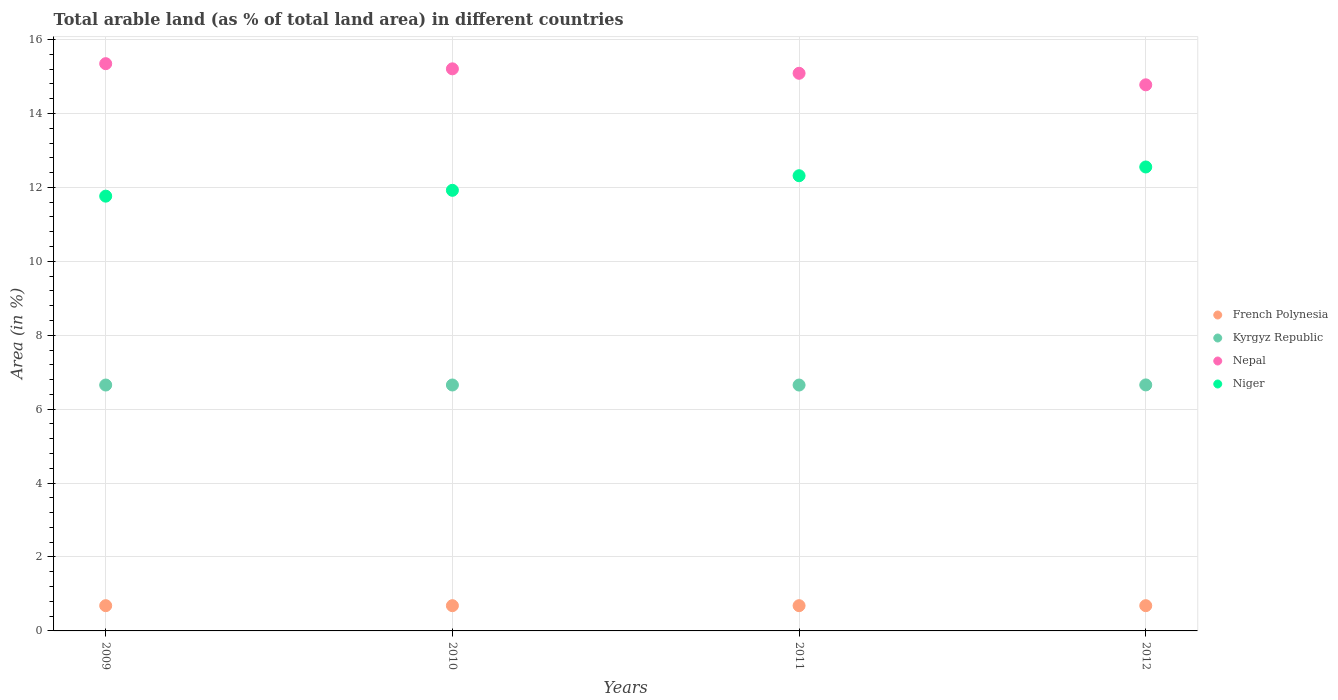Is the number of dotlines equal to the number of legend labels?
Your answer should be very brief. Yes. What is the percentage of arable land in French Polynesia in 2012?
Your answer should be compact. 0.68. Across all years, what is the maximum percentage of arable land in Nepal?
Ensure brevity in your answer.  15.35. Across all years, what is the minimum percentage of arable land in Kyrgyz Republic?
Make the answer very short. 6.65. In which year was the percentage of arable land in Niger maximum?
Give a very brief answer. 2012. In which year was the percentage of arable land in Nepal minimum?
Make the answer very short. 2012. What is the total percentage of arable land in Niger in the graph?
Ensure brevity in your answer.  48.55. What is the difference between the percentage of arable land in Kyrgyz Republic in 2009 and that in 2010?
Your response must be concise. -0. What is the difference between the percentage of arable land in Nepal in 2011 and the percentage of arable land in Niger in 2012?
Ensure brevity in your answer.  2.53. What is the average percentage of arable land in Nepal per year?
Your response must be concise. 15.1. In the year 2011, what is the difference between the percentage of arable land in Nepal and percentage of arable land in Niger?
Your answer should be very brief. 2.77. In how many years, is the percentage of arable land in Nepal greater than 4 %?
Provide a succinct answer. 4. What is the ratio of the percentage of arable land in Kyrgyz Republic in 2009 to that in 2012?
Provide a short and direct response. 1. Is the difference between the percentage of arable land in Nepal in 2009 and 2011 greater than the difference between the percentage of arable land in Niger in 2009 and 2011?
Your answer should be very brief. Yes. What is the difference between the highest and the second highest percentage of arable land in Niger?
Offer a terse response. 0.24. What is the difference between the highest and the lowest percentage of arable land in French Polynesia?
Keep it short and to the point. 0. In how many years, is the percentage of arable land in Nepal greater than the average percentage of arable land in Nepal taken over all years?
Your response must be concise. 2. Is it the case that in every year, the sum of the percentage of arable land in Nepal and percentage of arable land in French Polynesia  is greater than the sum of percentage of arable land in Niger and percentage of arable land in Kyrgyz Republic?
Provide a succinct answer. No. Is it the case that in every year, the sum of the percentage of arable land in French Polynesia and percentage of arable land in Nepal  is greater than the percentage of arable land in Kyrgyz Republic?
Provide a succinct answer. Yes. Is the percentage of arable land in French Polynesia strictly less than the percentage of arable land in Kyrgyz Republic over the years?
Your answer should be very brief. Yes. How many dotlines are there?
Provide a short and direct response. 4. How many years are there in the graph?
Provide a short and direct response. 4. What is the difference between two consecutive major ticks on the Y-axis?
Your answer should be very brief. 2. Does the graph contain grids?
Give a very brief answer. Yes. How many legend labels are there?
Ensure brevity in your answer.  4. What is the title of the graph?
Keep it short and to the point. Total arable land (as % of total land area) in different countries. What is the label or title of the X-axis?
Your answer should be very brief. Years. What is the label or title of the Y-axis?
Make the answer very short. Area (in %). What is the Area (in %) in French Polynesia in 2009?
Your answer should be very brief. 0.68. What is the Area (in %) in Kyrgyz Republic in 2009?
Your answer should be compact. 6.65. What is the Area (in %) of Nepal in 2009?
Provide a succinct answer. 15.35. What is the Area (in %) in Niger in 2009?
Your answer should be compact. 11.76. What is the Area (in %) of French Polynesia in 2010?
Your response must be concise. 0.68. What is the Area (in %) in Kyrgyz Republic in 2010?
Ensure brevity in your answer.  6.65. What is the Area (in %) of Nepal in 2010?
Ensure brevity in your answer.  15.21. What is the Area (in %) in Niger in 2010?
Offer a terse response. 11.92. What is the Area (in %) of French Polynesia in 2011?
Offer a very short reply. 0.68. What is the Area (in %) in Kyrgyz Republic in 2011?
Your response must be concise. 6.65. What is the Area (in %) in Nepal in 2011?
Offer a very short reply. 15.09. What is the Area (in %) of Niger in 2011?
Your answer should be very brief. 12.32. What is the Area (in %) in French Polynesia in 2012?
Keep it short and to the point. 0.68. What is the Area (in %) of Kyrgyz Republic in 2012?
Provide a succinct answer. 6.66. What is the Area (in %) of Nepal in 2012?
Keep it short and to the point. 14.78. What is the Area (in %) in Niger in 2012?
Make the answer very short. 12.55. Across all years, what is the maximum Area (in %) of French Polynesia?
Provide a short and direct response. 0.68. Across all years, what is the maximum Area (in %) of Kyrgyz Republic?
Your response must be concise. 6.66. Across all years, what is the maximum Area (in %) in Nepal?
Make the answer very short. 15.35. Across all years, what is the maximum Area (in %) in Niger?
Provide a short and direct response. 12.55. Across all years, what is the minimum Area (in %) in French Polynesia?
Offer a very short reply. 0.68. Across all years, what is the minimum Area (in %) in Kyrgyz Republic?
Your answer should be very brief. 6.65. Across all years, what is the minimum Area (in %) of Nepal?
Keep it short and to the point. 14.78. Across all years, what is the minimum Area (in %) in Niger?
Offer a very short reply. 11.76. What is the total Area (in %) in French Polynesia in the graph?
Provide a succinct answer. 2.73. What is the total Area (in %) in Kyrgyz Republic in the graph?
Keep it short and to the point. 26.61. What is the total Area (in %) in Nepal in the graph?
Offer a very short reply. 60.42. What is the total Area (in %) in Niger in the graph?
Make the answer very short. 48.55. What is the difference between the Area (in %) of French Polynesia in 2009 and that in 2010?
Give a very brief answer. 0. What is the difference between the Area (in %) of Kyrgyz Republic in 2009 and that in 2010?
Keep it short and to the point. -0. What is the difference between the Area (in %) in Nepal in 2009 and that in 2010?
Ensure brevity in your answer.  0.14. What is the difference between the Area (in %) in Niger in 2009 and that in 2010?
Give a very brief answer. -0.16. What is the difference between the Area (in %) of Nepal in 2009 and that in 2011?
Provide a succinct answer. 0.26. What is the difference between the Area (in %) in Niger in 2009 and that in 2011?
Make the answer very short. -0.55. What is the difference between the Area (in %) of French Polynesia in 2009 and that in 2012?
Give a very brief answer. 0. What is the difference between the Area (in %) in Kyrgyz Republic in 2009 and that in 2012?
Provide a short and direct response. -0. What is the difference between the Area (in %) in Nepal in 2009 and that in 2012?
Keep it short and to the point. 0.57. What is the difference between the Area (in %) in Niger in 2009 and that in 2012?
Keep it short and to the point. -0.79. What is the difference between the Area (in %) of Kyrgyz Republic in 2010 and that in 2011?
Make the answer very short. 0. What is the difference between the Area (in %) of Nepal in 2010 and that in 2011?
Give a very brief answer. 0.12. What is the difference between the Area (in %) of Niger in 2010 and that in 2011?
Give a very brief answer. -0.39. What is the difference between the Area (in %) of French Polynesia in 2010 and that in 2012?
Provide a short and direct response. 0. What is the difference between the Area (in %) in Kyrgyz Republic in 2010 and that in 2012?
Offer a very short reply. -0. What is the difference between the Area (in %) in Nepal in 2010 and that in 2012?
Ensure brevity in your answer.  0.43. What is the difference between the Area (in %) of Niger in 2010 and that in 2012?
Make the answer very short. -0.63. What is the difference between the Area (in %) of French Polynesia in 2011 and that in 2012?
Ensure brevity in your answer.  0. What is the difference between the Area (in %) in Kyrgyz Republic in 2011 and that in 2012?
Your response must be concise. -0. What is the difference between the Area (in %) of Nepal in 2011 and that in 2012?
Ensure brevity in your answer.  0.31. What is the difference between the Area (in %) of Niger in 2011 and that in 2012?
Provide a short and direct response. -0.24. What is the difference between the Area (in %) of French Polynesia in 2009 and the Area (in %) of Kyrgyz Republic in 2010?
Offer a terse response. -5.97. What is the difference between the Area (in %) in French Polynesia in 2009 and the Area (in %) in Nepal in 2010?
Provide a short and direct response. -14.52. What is the difference between the Area (in %) of French Polynesia in 2009 and the Area (in %) of Niger in 2010?
Offer a very short reply. -11.24. What is the difference between the Area (in %) of Kyrgyz Republic in 2009 and the Area (in %) of Nepal in 2010?
Your answer should be compact. -8.55. What is the difference between the Area (in %) of Kyrgyz Republic in 2009 and the Area (in %) of Niger in 2010?
Your answer should be compact. -5.27. What is the difference between the Area (in %) in Nepal in 2009 and the Area (in %) in Niger in 2010?
Ensure brevity in your answer.  3.43. What is the difference between the Area (in %) in French Polynesia in 2009 and the Area (in %) in Kyrgyz Republic in 2011?
Provide a short and direct response. -5.97. What is the difference between the Area (in %) of French Polynesia in 2009 and the Area (in %) of Nepal in 2011?
Your answer should be compact. -14.4. What is the difference between the Area (in %) in French Polynesia in 2009 and the Area (in %) in Niger in 2011?
Give a very brief answer. -11.63. What is the difference between the Area (in %) of Kyrgyz Republic in 2009 and the Area (in %) of Nepal in 2011?
Keep it short and to the point. -8.43. What is the difference between the Area (in %) of Kyrgyz Republic in 2009 and the Area (in %) of Niger in 2011?
Provide a short and direct response. -5.66. What is the difference between the Area (in %) in Nepal in 2009 and the Area (in %) in Niger in 2011?
Keep it short and to the point. 3.03. What is the difference between the Area (in %) in French Polynesia in 2009 and the Area (in %) in Kyrgyz Republic in 2012?
Offer a very short reply. -5.97. What is the difference between the Area (in %) of French Polynesia in 2009 and the Area (in %) of Nepal in 2012?
Your answer should be very brief. -14.09. What is the difference between the Area (in %) in French Polynesia in 2009 and the Area (in %) in Niger in 2012?
Make the answer very short. -11.87. What is the difference between the Area (in %) in Kyrgyz Republic in 2009 and the Area (in %) in Nepal in 2012?
Give a very brief answer. -8.12. What is the difference between the Area (in %) in Kyrgyz Republic in 2009 and the Area (in %) in Niger in 2012?
Your response must be concise. -5.9. What is the difference between the Area (in %) of Nepal in 2009 and the Area (in %) of Niger in 2012?
Ensure brevity in your answer.  2.79. What is the difference between the Area (in %) in French Polynesia in 2010 and the Area (in %) in Kyrgyz Republic in 2011?
Your answer should be compact. -5.97. What is the difference between the Area (in %) of French Polynesia in 2010 and the Area (in %) of Nepal in 2011?
Keep it short and to the point. -14.4. What is the difference between the Area (in %) of French Polynesia in 2010 and the Area (in %) of Niger in 2011?
Provide a succinct answer. -11.63. What is the difference between the Area (in %) in Kyrgyz Republic in 2010 and the Area (in %) in Nepal in 2011?
Give a very brief answer. -8.43. What is the difference between the Area (in %) in Kyrgyz Republic in 2010 and the Area (in %) in Niger in 2011?
Provide a succinct answer. -5.66. What is the difference between the Area (in %) in Nepal in 2010 and the Area (in %) in Niger in 2011?
Ensure brevity in your answer.  2.89. What is the difference between the Area (in %) of French Polynesia in 2010 and the Area (in %) of Kyrgyz Republic in 2012?
Give a very brief answer. -5.97. What is the difference between the Area (in %) in French Polynesia in 2010 and the Area (in %) in Nepal in 2012?
Ensure brevity in your answer.  -14.09. What is the difference between the Area (in %) in French Polynesia in 2010 and the Area (in %) in Niger in 2012?
Keep it short and to the point. -11.87. What is the difference between the Area (in %) in Kyrgyz Republic in 2010 and the Area (in %) in Nepal in 2012?
Make the answer very short. -8.12. What is the difference between the Area (in %) in Kyrgyz Republic in 2010 and the Area (in %) in Niger in 2012?
Make the answer very short. -5.9. What is the difference between the Area (in %) of Nepal in 2010 and the Area (in %) of Niger in 2012?
Provide a succinct answer. 2.66. What is the difference between the Area (in %) of French Polynesia in 2011 and the Area (in %) of Kyrgyz Republic in 2012?
Keep it short and to the point. -5.97. What is the difference between the Area (in %) in French Polynesia in 2011 and the Area (in %) in Nepal in 2012?
Your answer should be very brief. -14.09. What is the difference between the Area (in %) in French Polynesia in 2011 and the Area (in %) in Niger in 2012?
Your answer should be very brief. -11.87. What is the difference between the Area (in %) in Kyrgyz Republic in 2011 and the Area (in %) in Nepal in 2012?
Provide a succinct answer. -8.12. What is the difference between the Area (in %) in Kyrgyz Republic in 2011 and the Area (in %) in Niger in 2012?
Provide a short and direct response. -5.9. What is the difference between the Area (in %) in Nepal in 2011 and the Area (in %) in Niger in 2012?
Your answer should be very brief. 2.53. What is the average Area (in %) in French Polynesia per year?
Ensure brevity in your answer.  0.68. What is the average Area (in %) in Kyrgyz Republic per year?
Ensure brevity in your answer.  6.65. What is the average Area (in %) in Nepal per year?
Provide a succinct answer. 15.1. What is the average Area (in %) in Niger per year?
Provide a succinct answer. 12.14. In the year 2009, what is the difference between the Area (in %) of French Polynesia and Area (in %) of Kyrgyz Republic?
Offer a terse response. -5.97. In the year 2009, what is the difference between the Area (in %) of French Polynesia and Area (in %) of Nepal?
Your answer should be compact. -14.66. In the year 2009, what is the difference between the Area (in %) in French Polynesia and Area (in %) in Niger?
Offer a very short reply. -11.08. In the year 2009, what is the difference between the Area (in %) of Kyrgyz Republic and Area (in %) of Nepal?
Your answer should be very brief. -8.69. In the year 2009, what is the difference between the Area (in %) of Kyrgyz Republic and Area (in %) of Niger?
Ensure brevity in your answer.  -5.11. In the year 2009, what is the difference between the Area (in %) of Nepal and Area (in %) of Niger?
Make the answer very short. 3.58. In the year 2010, what is the difference between the Area (in %) in French Polynesia and Area (in %) in Kyrgyz Republic?
Your answer should be compact. -5.97. In the year 2010, what is the difference between the Area (in %) of French Polynesia and Area (in %) of Nepal?
Provide a short and direct response. -14.52. In the year 2010, what is the difference between the Area (in %) in French Polynesia and Area (in %) in Niger?
Make the answer very short. -11.24. In the year 2010, what is the difference between the Area (in %) in Kyrgyz Republic and Area (in %) in Nepal?
Keep it short and to the point. -8.55. In the year 2010, what is the difference between the Area (in %) of Kyrgyz Republic and Area (in %) of Niger?
Your answer should be very brief. -5.27. In the year 2010, what is the difference between the Area (in %) in Nepal and Area (in %) in Niger?
Your response must be concise. 3.29. In the year 2011, what is the difference between the Area (in %) of French Polynesia and Area (in %) of Kyrgyz Republic?
Offer a terse response. -5.97. In the year 2011, what is the difference between the Area (in %) in French Polynesia and Area (in %) in Nepal?
Offer a terse response. -14.4. In the year 2011, what is the difference between the Area (in %) of French Polynesia and Area (in %) of Niger?
Offer a very short reply. -11.63. In the year 2011, what is the difference between the Area (in %) in Kyrgyz Republic and Area (in %) in Nepal?
Ensure brevity in your answer.  -8.43. In the year 2011, what is the difference between the Area (in %) of Kyrgyz Republic and Area (in %) of Niger?
Provide a succinct answer. -5.66. In the year 2011, what is the difference between the Area (in %) of Nepal and Area (in %) of Niger?
Provide a short and direct response. 2.77. In the year 2012, what is the difference between the Area (in %) in French Polynesia and Area (in %) in Kyrgyz Republic?
Offer a very short reply. -5.97. In the year 2012, what is the difference between the Area (in %) of French Polynesia and Area (in %) of Nepal?
Your response must be concise. -14.09. In the year 2012, what is the difference between the Area (in %) of French Polynesia and Area (in %) of Niger?
Your answer should be very brief. -11.87. In the year 2012, what is the difference between the Area (in %) in Kyrgyz Republic and Area (in %) in Nepal?
Keep it short and to the point. -8.12. In the year 2012, what is the difference between the Area (in %) of Kyrgyz Republic and Area (in %) of Niger?
Offer a terse response. -5.9. In the year 2012, what is the difference between the Area (in %) in Nepal and Area (in %) in Niger?
Keep it short and to the point. 2.22. What is the ratio of the Area (in %) of French Polynesia in 2009 to that in 2010?
Your answer should be very brief. 1. What is the ratio of the Area (in %) in Nepal in 2009 to that in 2010?
Offer a very short reply. 1.01. What is the ratio of the Area (in %) in Kyrgyz Republic in 2009 to that in 2011?
Your answer should be very brief. 1. What is the ratio of the Area (in %) in Nepal in 2009 to that in 2011?
Offer a terse response. 1.02. What is the ratio of the Area (in %) of Niger in 2009 to that in 2011?
Keep it short and to the point. 0.96. What is the ratio of the Area (in %) of French Polynesia in 2009 to that in 2012?
Ensure brevity in your answer.  1. What is the ratio of the Area (in %) of Kyrgyz Republic in 2009 to that in 2012?
Provide a short and direct response. 1. What is the ratio of the Area (in %) of Nepal in 2009 to that in 2012?
Provide a succinct answer. 1.04. What is the ratio of the Area (in %) of Niger in 2009 to that in 2012?
Make the answer very short. 0.94. What is the ratio of the Area (in %) in French Polynesia in 2010 to that in 2011?
Offer a terse response. 1. What is the ratio of the Area (in %) of Nepal in 2010 to that in 2011?
Make the answer very short. 1.01. What is the ratio of the Area (in %) in Niger in 2010 to that in 2011?
Provide a succinct answer. 0.97. What is the ratio of the Area (in %) in French Polynesia in 2010 to that in 2012?
Make the answer very short. 1. What is the ratio of the Area (in %) in Nepal in 2010 to that in 2012?
Make the answer very short. 1.03. What is the ratio of the Area (in %) in Niger in 2010 to that in 2012?
Provide a short and direct response. 0.95. What is the ratio of the Area (in %) of French Polynesia in 2011 to that in 2012?
Offer a terse response. 1. What is the ratio of the Area (in %) of Nepal in 2011 to that in 2012?
Offer a very short reply. 1.02. What is the ratio of the Area (in %) of Niger in 2011 to that in 2012?
Your answer should be compact. 0.98. What is the difference between the highest and the second highest Area (in %) in Kyrgyz Republic?
Ensure brevity in your answer.  0. What is the difference between the highest and the second highest Area (in %) of Nepal?
Provide a succinct answer. 0.14. What is the difference between the highest and the second highest Area (in %) of Niger?
Provide a short and direct response. 0.24. What is the difference between the highest and the lowest Area (in %) in French Polynesia?
Give a very brief answer. 0. What is the difference between the highest and the lowest Area (in %) in Kyrgyz Republic?
Offer a terse response. 0. What is the difference between the highest and the lowest Area (in %) in Nepal?
Make the answer very short. 0.57. What is the difference between the highest and the lowest Area (in %) of Niger?
Keep it short and to the point. 0.79. 